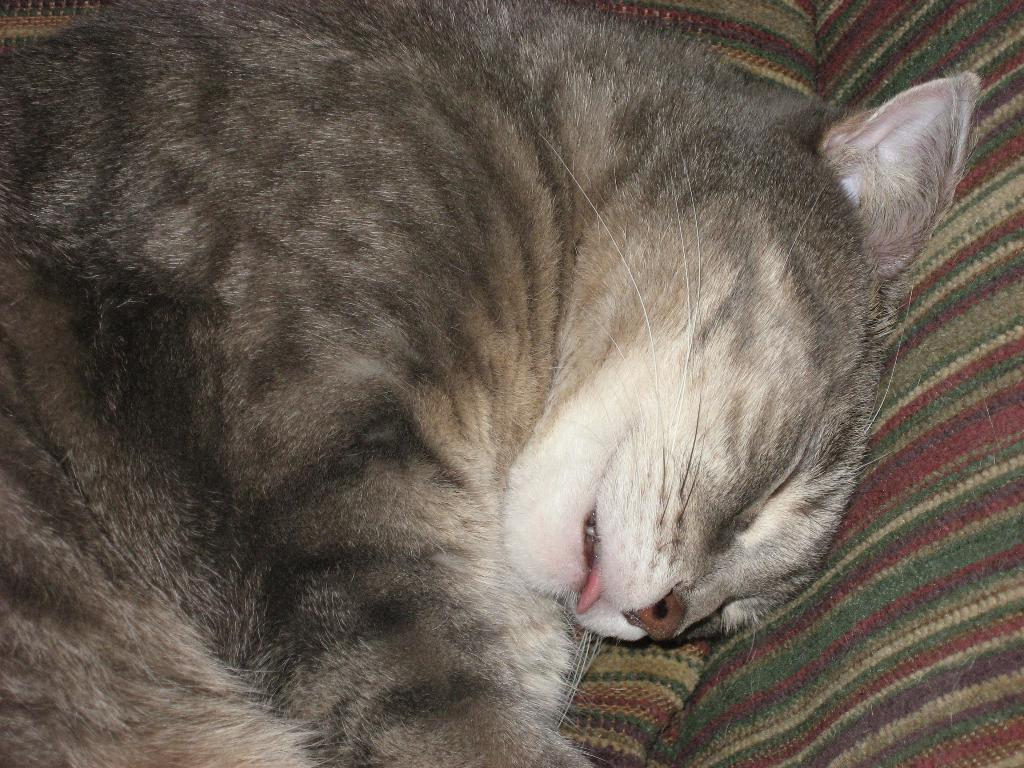What type of animal is in the image? There is a cat in the image. What is the cat doing in the image? The cat is sleeping in the image. Where is the cat located in the image? The cat is on a couch in the image. How many brothers does the cat have in the image? There is no information about the cat's brothers in the image. What type of expansion is visible in the image? There is no expansion visible in the image; it features a cat sleeping on a couch. 